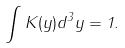<formula> <loc_0><loc_0><loc_500><loc_500>\int K ( y ) d ^ { 3 } y = 1 .</formula> 